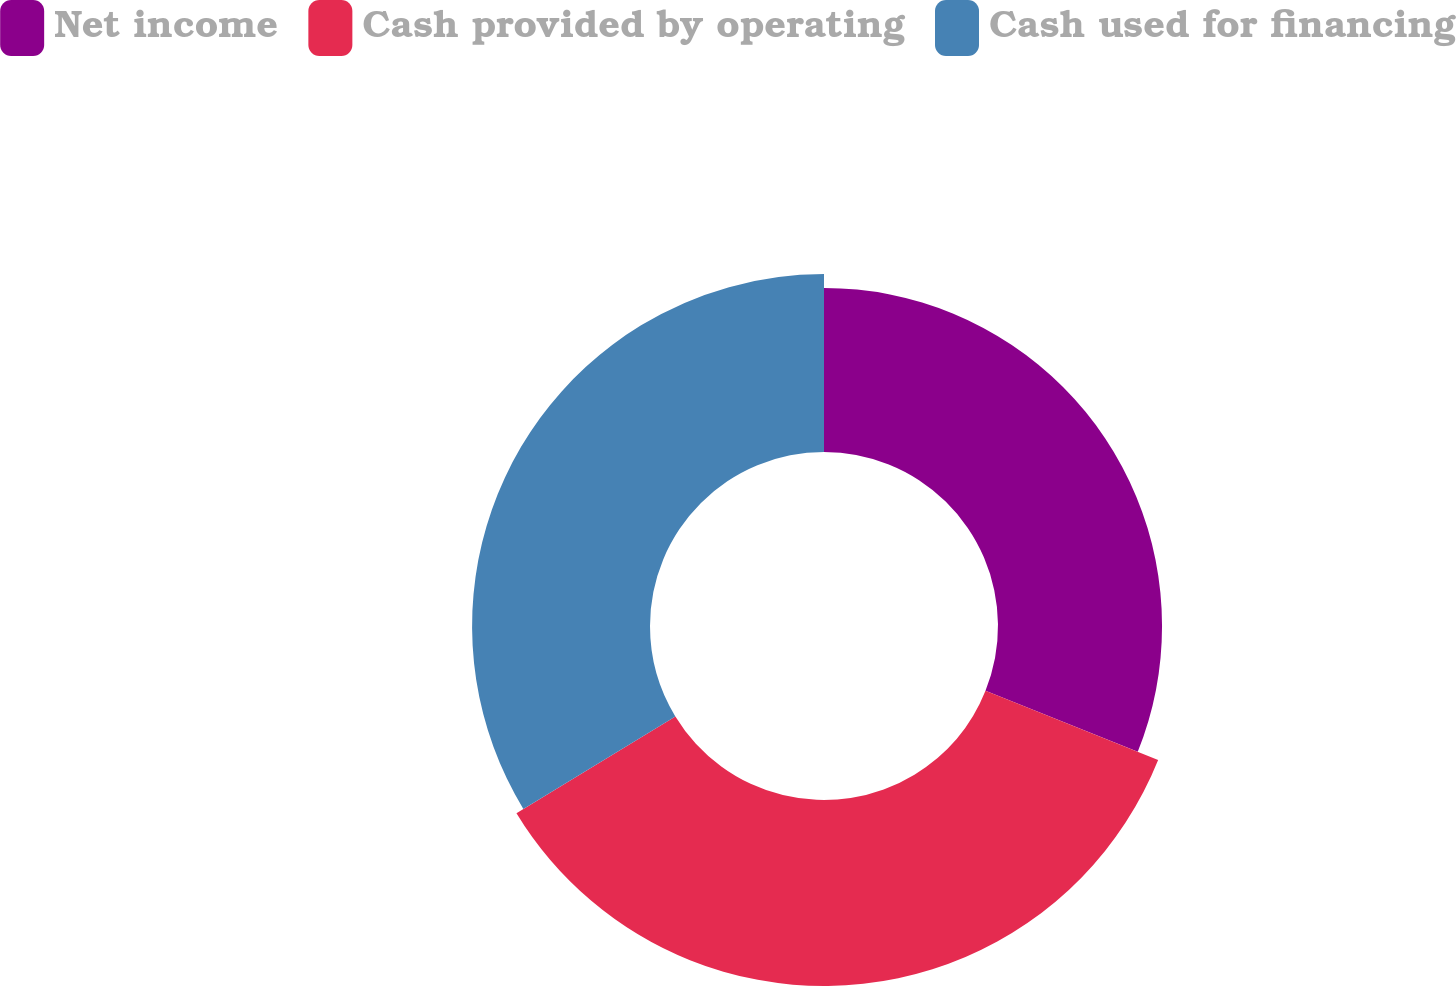<chart> <loc_0><loc_0><loc_500><loc_500><pie_chart><fcel>Net income<fcel>Cash provided by operating<fcel>Cash used for financing<nl><fcel>31.07%<fcel>35.23%<fcel>33.7%<nl></chart> 